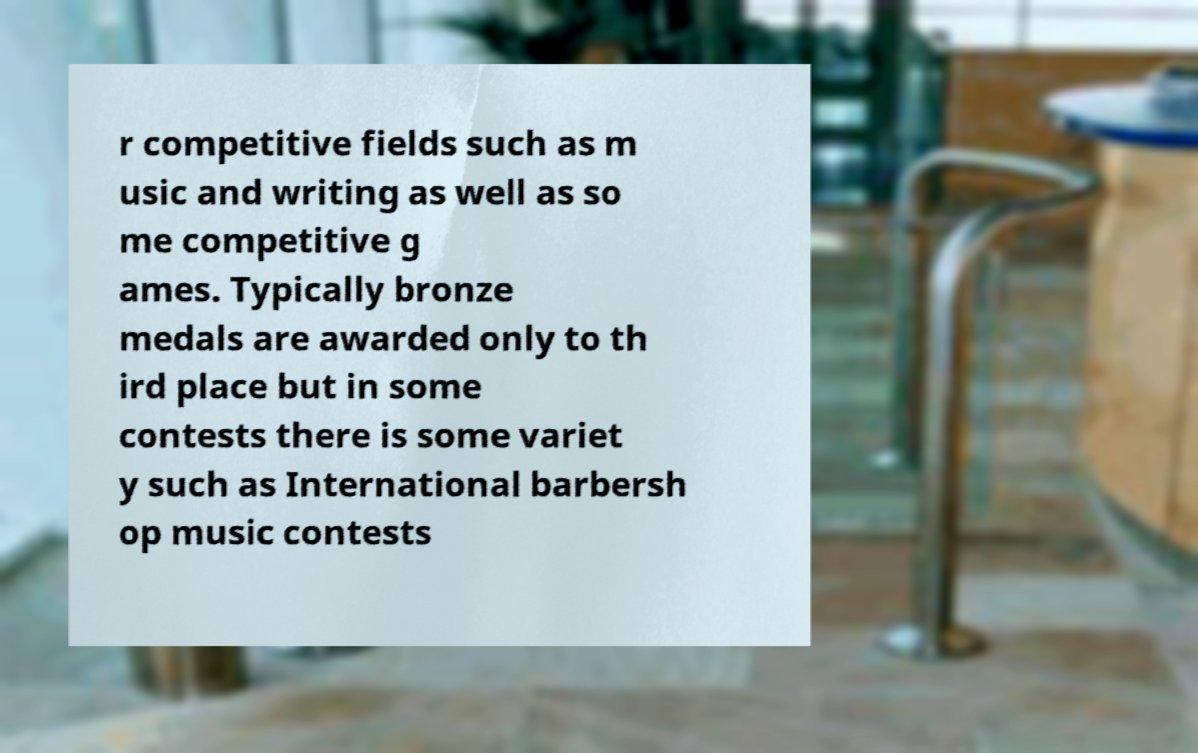There's text embedded in this image that I need extracted. Can you transcribe it verbatim? r competitive fields such as m usic and writing as well as so me competitive g ames. Typically bronze medals are awarded only to th ird place but in some contests there is some variet y such as International barbersh op music contests 